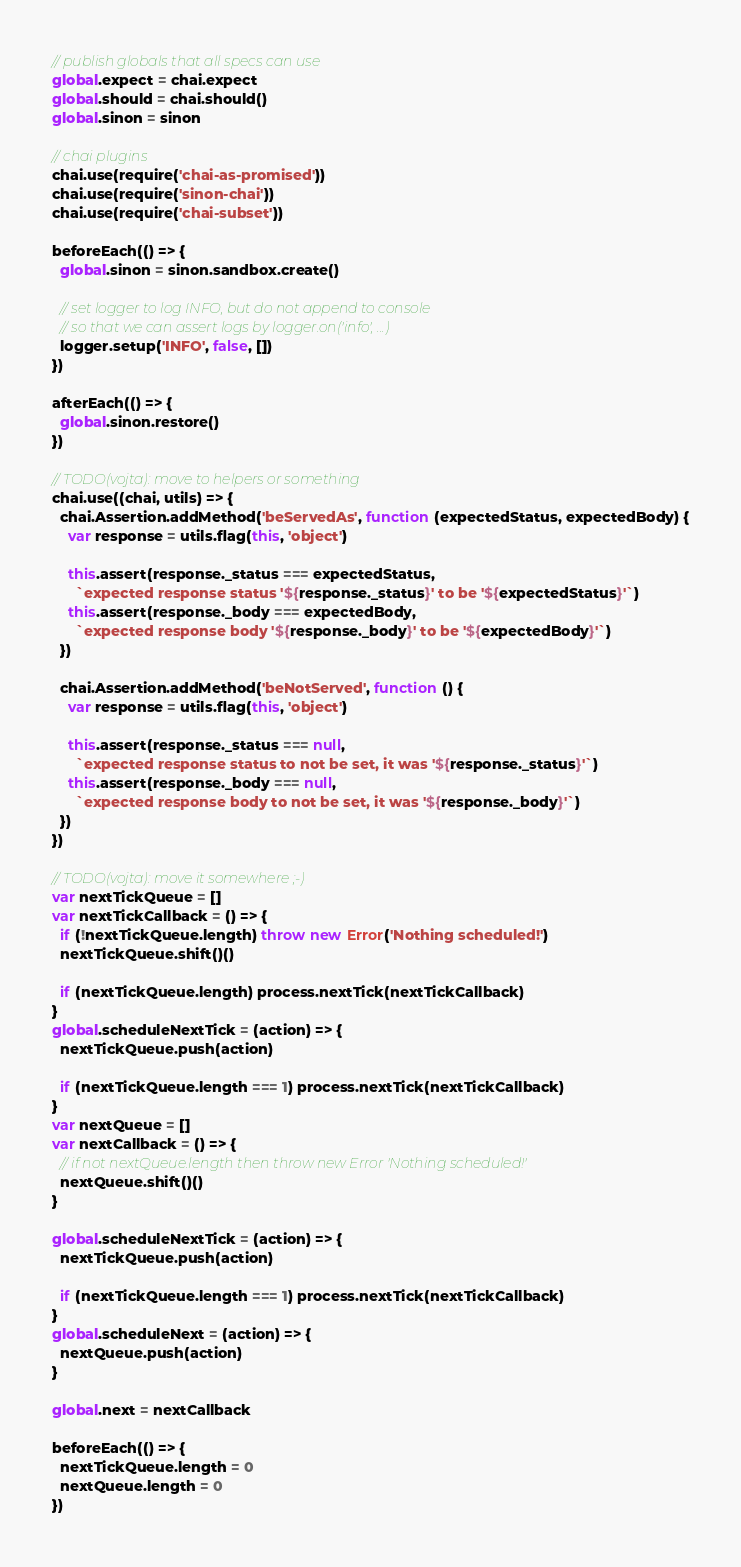<code> <loc_0><loc_0><loc_500><loc_500><_JavaScript_>// publish globals that all specs can use
global.expect = chai.expect
global.should = chai.should()
global.sinon = sinon

// chai plugins
chai.use(require('chai-as-promised'))
chai.use(require('sinon-chai'))
chai.use(require('chai-subset'))

beforeEach(() => {
  global.sinon = sinon.sandbox.create()

  // set logger to log INFO, but do not append to console
  // so that we can assert logs by logger.on('info', ...)
  logger.setup('INFO', false, [])
})

afterEach(() => {
  global.sinon.restore()
})

// TODO(vojta): move to helpers or something
chai.use((chai, utils) => {
  chai.Assertion.addMethod('beServedAs', function (expectedStatus, expectedBody) {
    var response = utils.flag(this, 'object')

    this.assert(response._status === expectedStatus,
      `expected response status '${response._status}' to be '${expectedStatus}'`)
    this.assert(response._body === expectedBody,
      `expected response body '${response._body}' to be '${expectedBody}'`)
  })

  chai.Assertion.addMethod('beNotServed', function () {
    var response = utils.flag(this, 'object')

    this.assert(response._status === null,
      `expected response status to not be set, it was '${response._status}'`)
    this.assert(response._body === null,
      `expected response body to not be set, it was '${response._body}'`)
  })
})

// TODO(vojta): move it somewhere ;-)
var nextTickQueue = []
var nextTickCallback = () => {
  if (!nextTickQueue.length) throw new Error('Nothing scheduled!')
  nextTickQueue.shift()()

  if (nextTickQueue.length) process.nextTick(nextTickCallback)
}
global.scheduleNextTick = (action) => {
  nextTickQueue.push(action)

  if (nextTickQueue.length === 1) process.nextTick(nextTickCallback)
}
var nextQueue = []
var nextCallback = () => {
  // if not nextQueue.length then throw new Error 'Nothing scheduled!'
  nextQueue.shift()()
}

global.scheduleNextTick = (action) => {
  nextTickQueue.push(action)

  if (nextTickQueue.length === 1) process.nextTick(nextTickCallback)
}
global.scheduleNext = (action) => {
  nextQueue.push(action)
}

global.next = nextCallback

beforeEach(() => {
  nextTickQueue.length = 0
  nextQueue.length = 0
})
</code> 